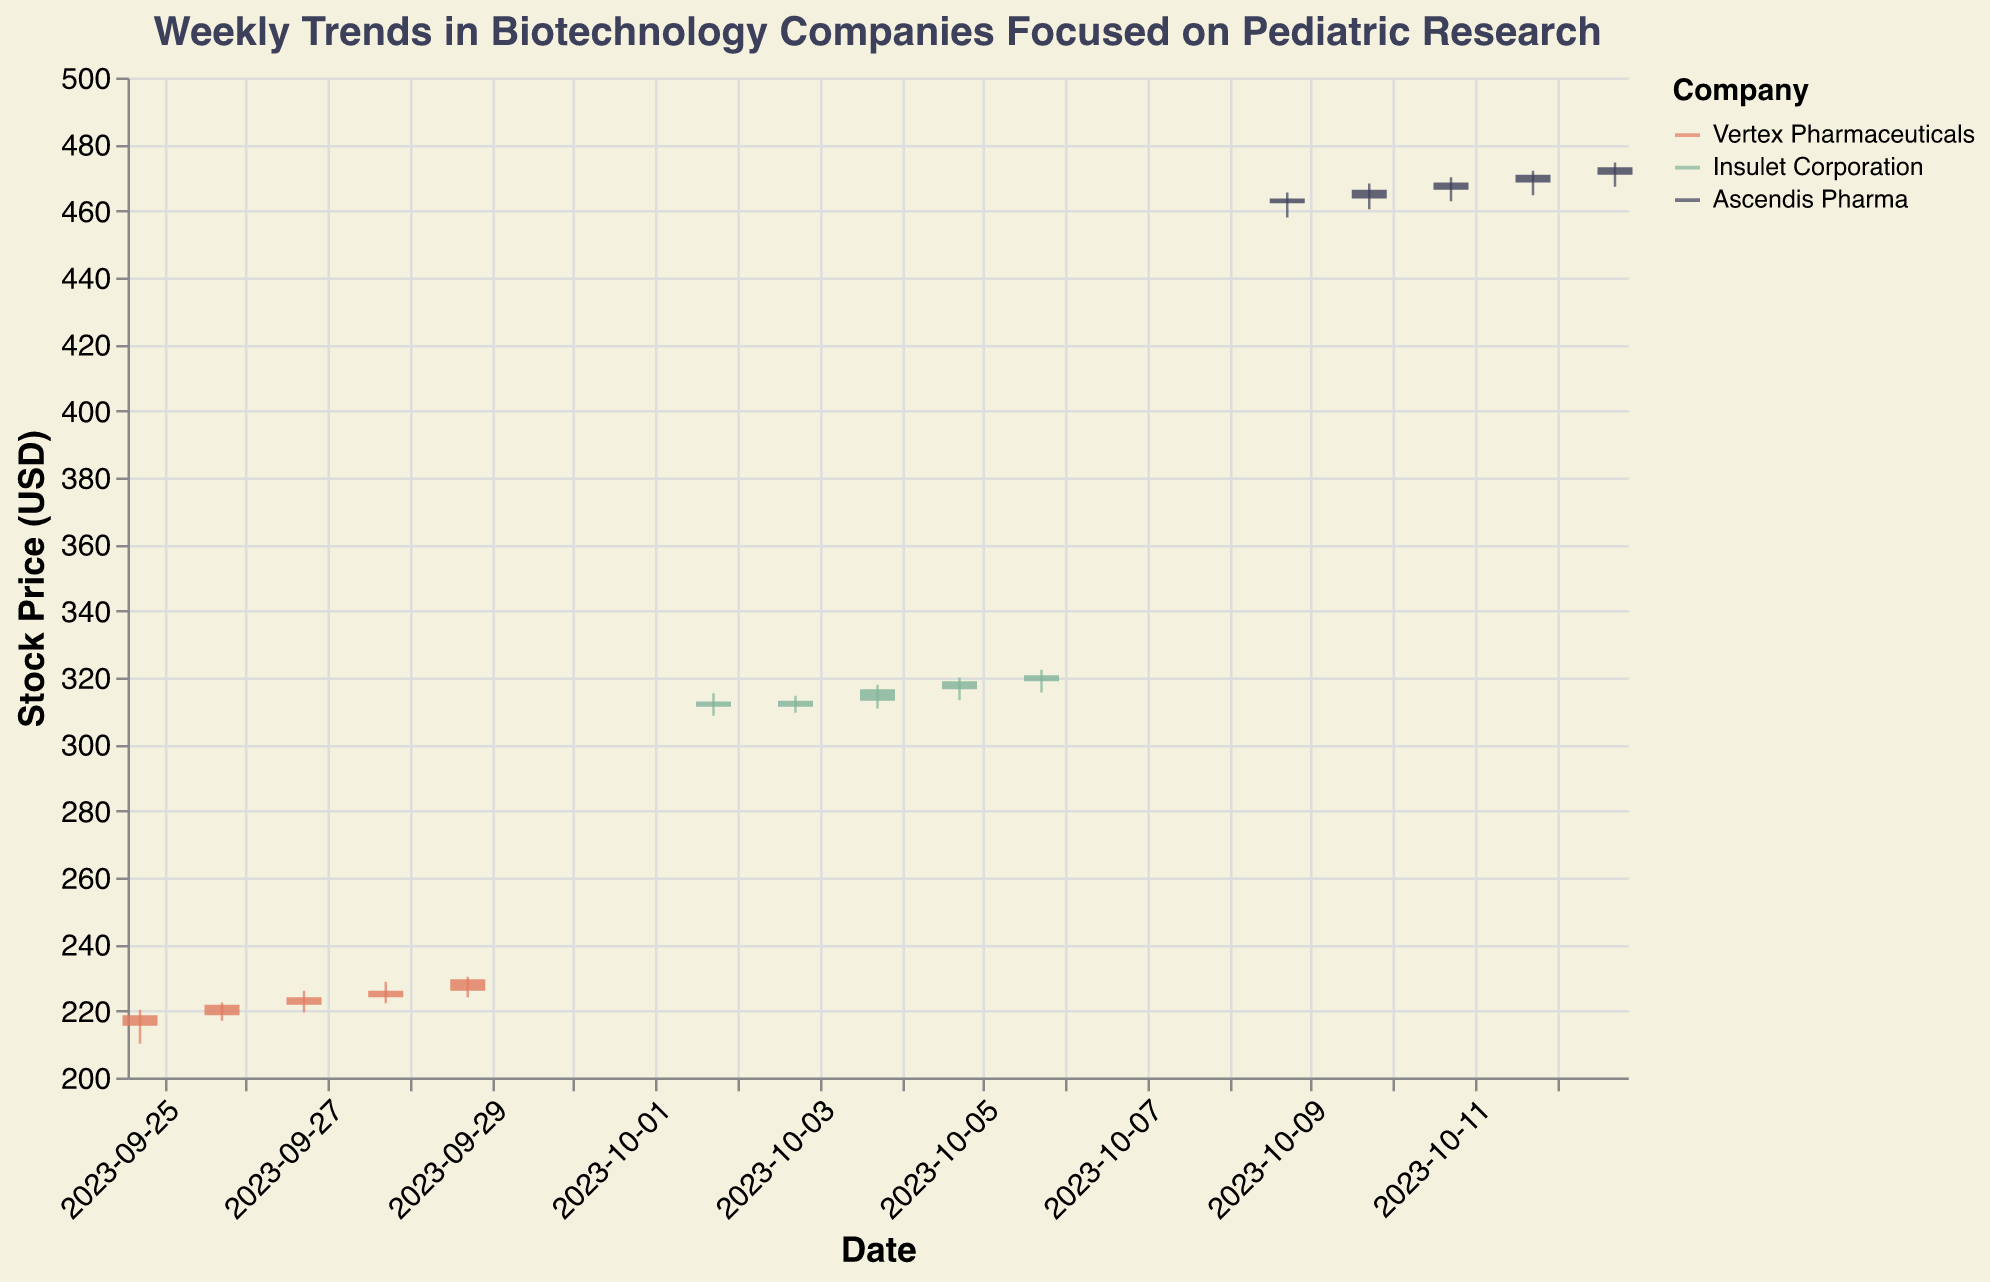What is the color used to represent Ascendis Pharma? The figure uses a specific color to represent each company. Ascendis Pharma is represented using a dark blue color.
Answer: Dark blue Which day had the highest closing price for Vertex Pharmaceuticals? To find the highest closing price for Vertex Pharmaceuticals, look at the 'Close' values for dates associated with the company. The highest is on 2023-09-29 with a closing price of 229.50.
Answer: 2023-09-29 What is the average closing price for Insulet Corporation from 2023-10-02 to 2023-10-06? To calculate the average, sum the closing prices for Insulet Corporation during that period (311.20, 313.00, 316.50, 318.90, 320.70) and divide by the number of days (5). The sum is 1580.30, so the average is 1580.30 / 5 = 316.06.
Answer: 316.06 Which company shows the highest increase in closing price within a week? Compare the increase in closing prices over the week for each company by subtracting the closing price at the start of the period from the closing price at the end. Ascendis Pharma's increase is the greatest (463.70 to 473.10, which is 9.4).
Answer: Ascendis Pharma What trend can be observed for Vertex Pharmaceuticals' stock price over the week? Examine the closing prices for Vertex Pharmaceuticals day-by-day from 2023-09-25 to 2023-09-29. The trend is consistently increasing from 218.70 to 229.50.
Answer: Increasing Between Insulet Corporation and Ascendis Pharma, which company had a higher trading volume on 2023-10-06? Compare the 'Volume' values for both companies on that date. Insulet Corporation had a volume of 1750000, while Ascendis Pharma had 1800000. Hence, Ascendis Pharma had the higher volume.
Answer: Ascendis Pharma How does the stock price volatility of Ascendis Pharma compare to Insulet Corporation? Assess the range between the highest and lowest prices ("High" and "Low") each day for both companies. Ascendis Pharma shows higher volatility with larger differences between high and low values compared to Insulet Corporation.
Answer: Ascendis Pharma What was the opening price for Vertex Pharmaceuticals on 2023-09-27? Look at the "Open" price for Vertex Pharmaceuticals on 2023-09-27. It is 221.80.
Answer: 221.80 How many companies are represented in the figure? Count the number of distinct companies listed in the data. The companies are Vertex Pharmaceuticals, Insulet Corporation, and Ascendis Pharma, making a total of three companies.
Answer: 3 